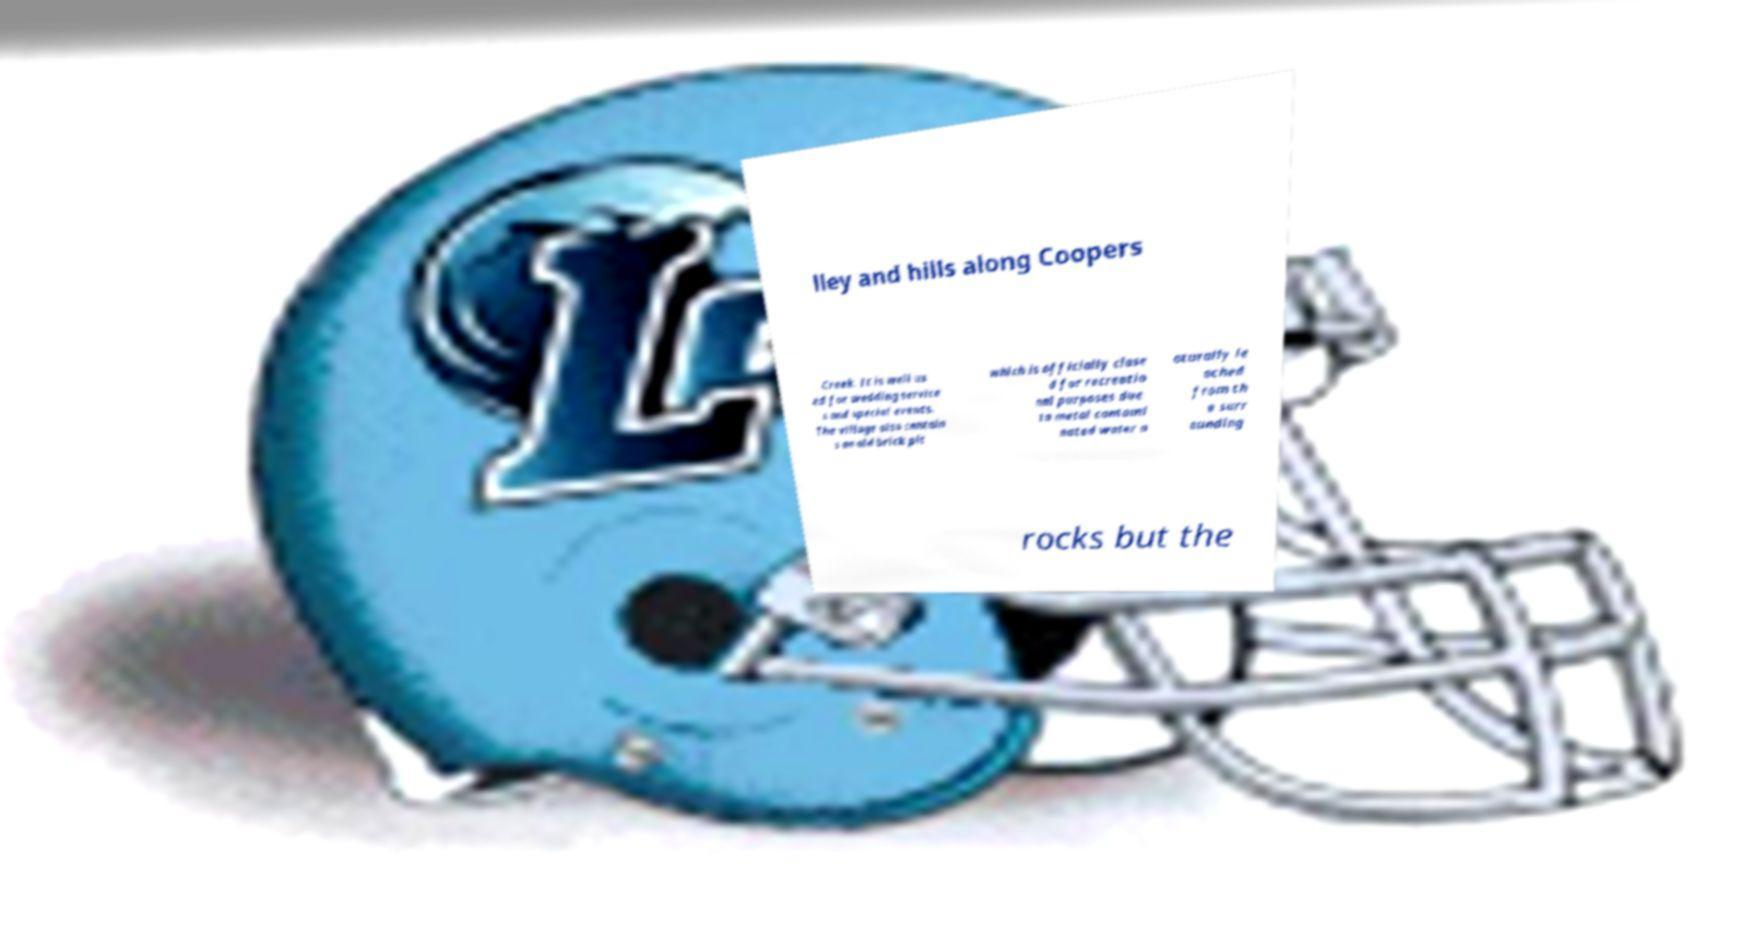For documentation purposes, I need the text within this image transcribed. Could you provide that? lley and hills along Coopers Creek. It is well us ed for wedding service s and special events. The village also contain s an old brick pit which is officially close d for recreatio nal purposes due to metal contami nated water n aturally le ached from th e surr ounding rocks but the 